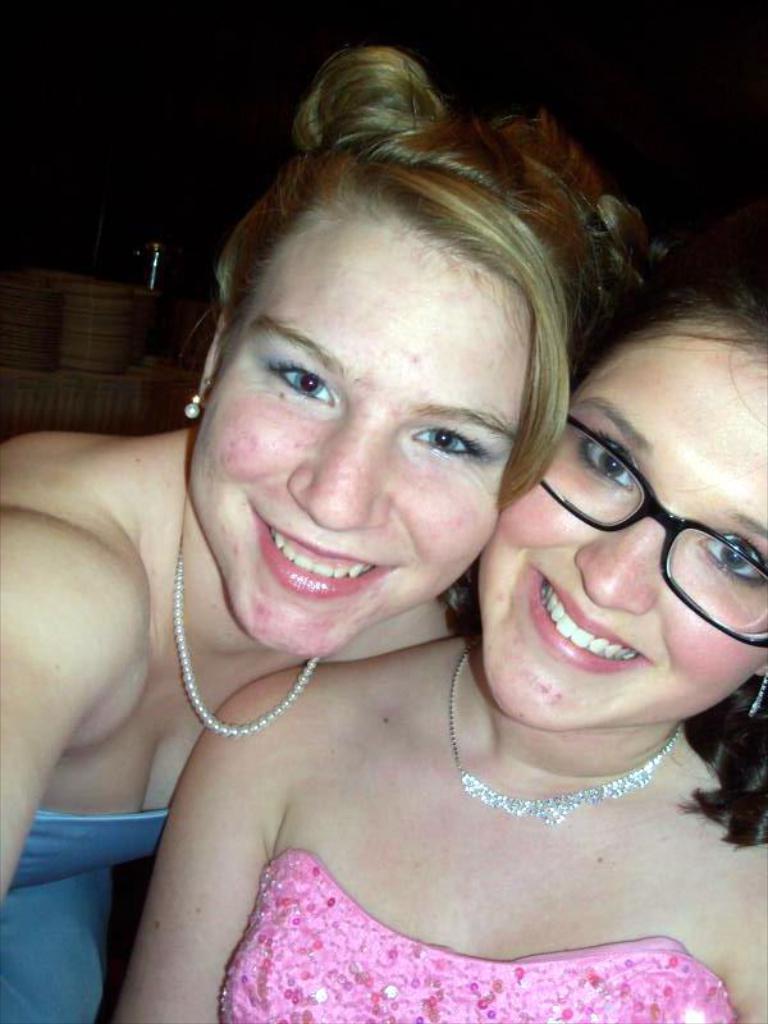In one or two sentences, can you explain what this image depicts? In this image we can see two women wearing pink and blue color dress, person wearing pink color dress also wearing spectacles and in the background of the image there are some plates which are on table. 